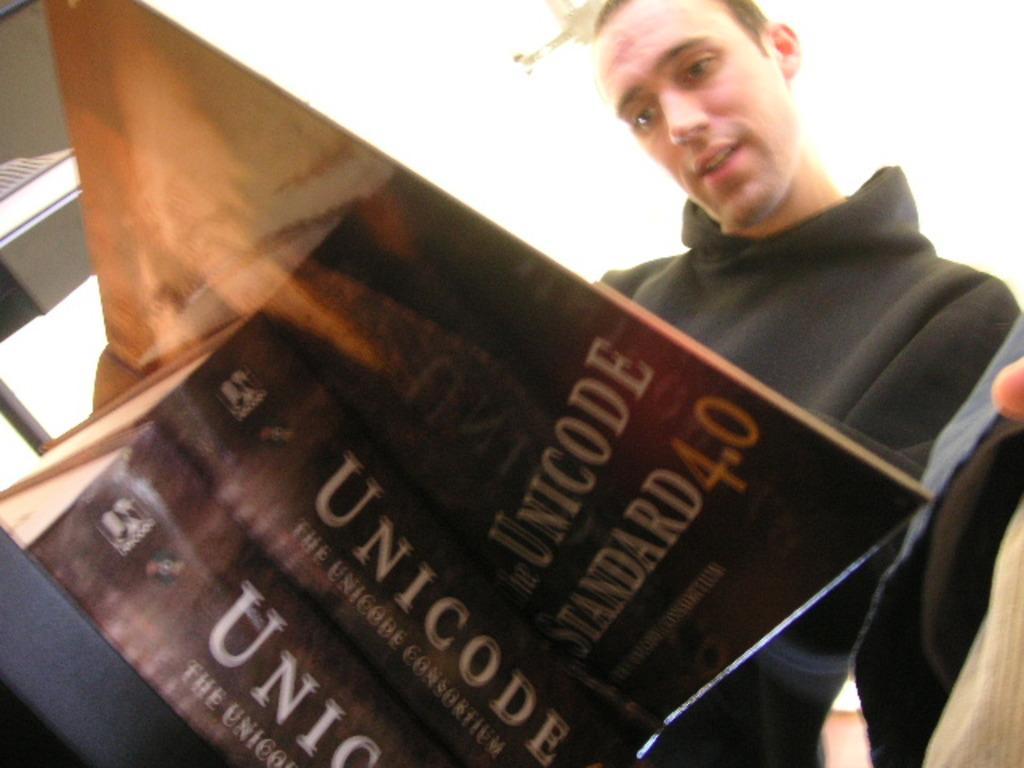Provide a one-sentence caption for the provided image. A man in a black hoodie looking down at an open book titled Unicode Standard 4.0 on top of a stack of two of the same book. 